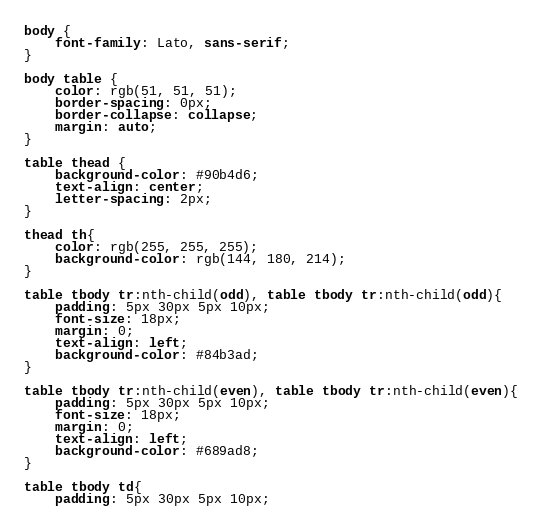Convert code to text. <code><loc_0><loc_0><loc_500><loc_500><_CSS_>body {
    font-family: Lato, sans-serif;
}

body table {
    color: rgb(51, 51, 51);
    border-spacing: 0px;
    border-collapse: collapse;
    margin: auto;
}

table thead {
    background-color: #90b4d6;
    text-align: center;
    letter-spacing: 2px;
}

thead th{
    color: rgb(255, 255, 255);
    background-color: rgb(144, 180, 214);
}

table tbody tr:nth-child(odd), table tbody tr:nth-child(odd){
    padding: 5px 30px 5px 10px;
    font-size: 18px;
    margin: 0;
    text-align: left;
    background-color: #84b3ad;
}

table tbody tr:nth-child(even), table tbody tr:nth-child(even){
    padding: 5px 30px 5px 10px;
    font-size: 18px;
    margin: 0;
    text-align: left;
    background-color: #689ad8;
}

table tbody td{
    padding: 5px 30px 5px 10px;</code> 